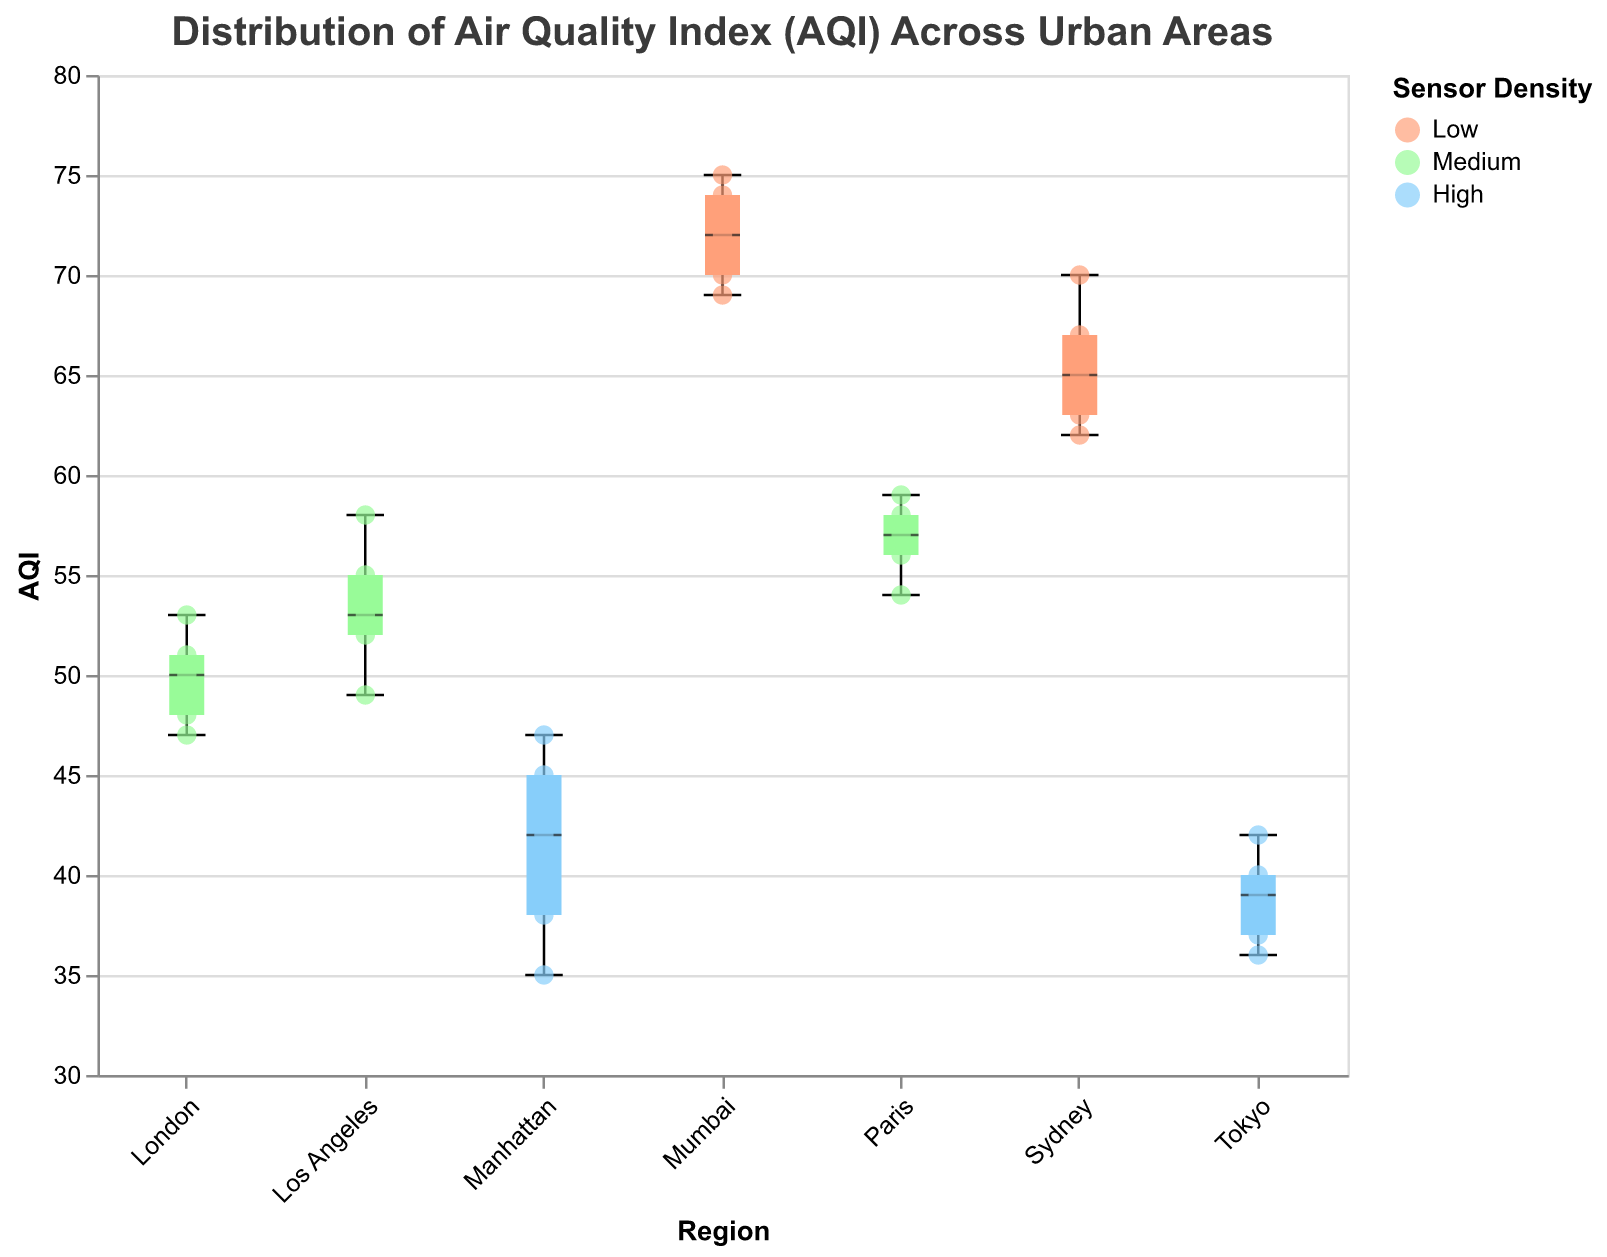What is the title of the figure? The title of the figure is usually placed at the top of the plot and describes what the plot is about. In this case, it describes the distribution of the AQI across various urban areas.
Answer: Distribution of Air Quality Index (AQI) Across Urban Areas What are the three categories of sensor density used in the figure? The categories of sensor density are represented by different colors in the plot legend. These categories are used to differentiate the data points from different sensor density regions.
Answer: Low, Medium, High Which region has the highest median AQI value? To find the highest median AQI value, look for the box plot with the middle line (median) positioned the highest on the y-axis.
Answer: Mumbai What is the range of AQI values in Manhattan? The range of AQI values is determined by the minimum and maximum values shown by the whiskers of the box plot. For Manhattan, check the positions of the whiskers.
Answer: 35 to 47 Among the regions with medium sensor density, which one has the highest maximum AQI value? Identify regions with medium sensor density from the legend colors. Then, look at the highest whisker points of these regions.
Answer: Paris How many regions have a median AQI value lower than 50? To find this, check the box plots and count the number of regions whose median line is below the 50 on the y-axis.
Answer: 4 regions (Manhattan, Tokyo, London, Sydney) Is the variability of AQI higher in Los Angeles or Tokyo? Variability can be assessed by comparing the interquartile ranges (IQRs), represented by the height of the boxes in the box plots of Los Angeles and Tokyo.
Answer: Los Angeles Do regions with low sensor density have higher AQI values compared to regions with high sensor density? Compare the AQI values (both median and overall range) of the regions categorized under low and high sensor densities.
Answer: Yes, regions with low sensor density have higher AQI values Which region has the highest AQI point among all the data points? Look for the scatter point that is highest on the y-axis across all regions.
Answer: Mumbai 